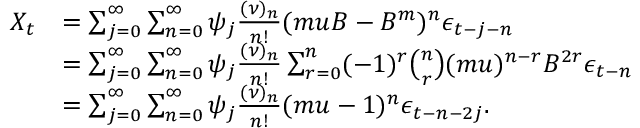<formula> <loc_0><loc_0><loc_500><loc_500>\begin{array} { r l } { X _ { t } } & { = \sum _ { j = 0 } ^ { \infty } \sum _ { n = 0 } ^ { \infty } \psi _ { j } \frac { ( \nu ) _ { n } } { n ! } ( m u B - B ^ { m } ) ^ { n } \epsilon _ { t - j - n } } \\ & { = \sum _ { j = 0 } ^ { \infty } \sum _ { n = 0 } ^ { \infty } \psi _ { j } { \frac { ( \nu ) _ { n } } { n ! } } \sum _ { r = 0 } ^ { n } ( - 1 ) ^ { r } \binom { n } { r } ( m u ) ^ { n - r } B ^ { 2 r } \epsilon _ { t - n } } \\ & { = \sum _ { j = 0 } ^ { \infty } \sum _ { n = 0 } ^ { \infty } \psi _ { j } { \frac { ( \nu ) _ { n } } { n ! } } ( m u - 1 ) ^ { n } \epsilon _ { t - n - 2 j } . } \end{array}</formula> 